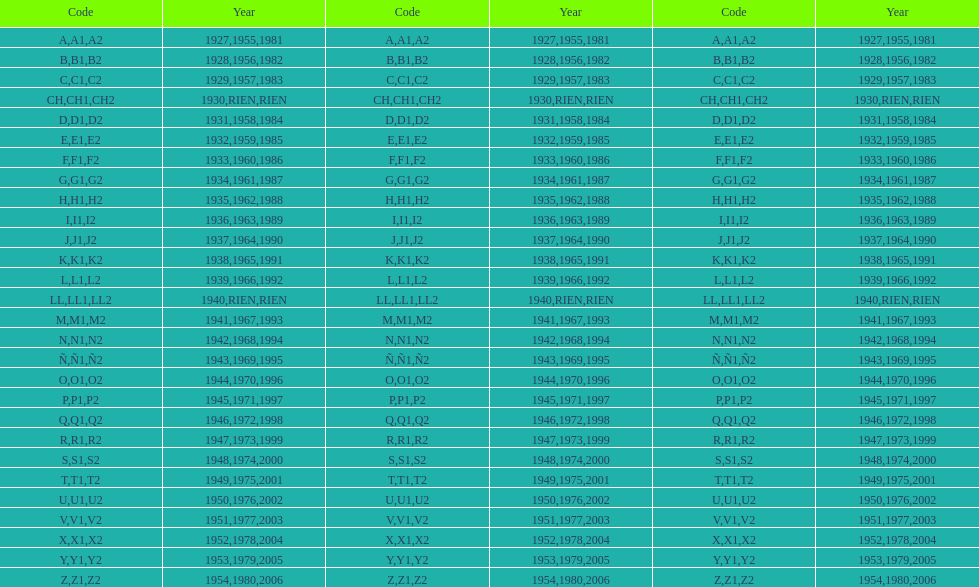Other than 1927 what year did the code start with a? 1955, 1981. 